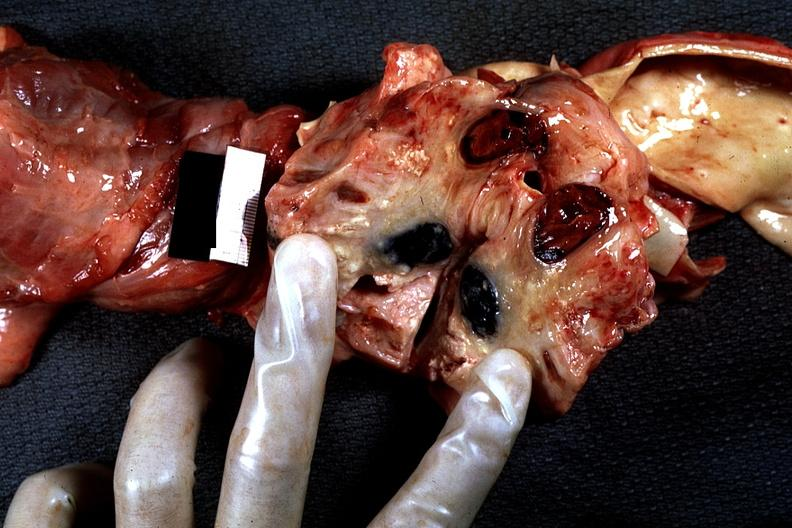what does this image show?
Answer the question using a single word or phrase. Metastatic carcinoma surrounding cava superior caval syndrome lung carcinoma 